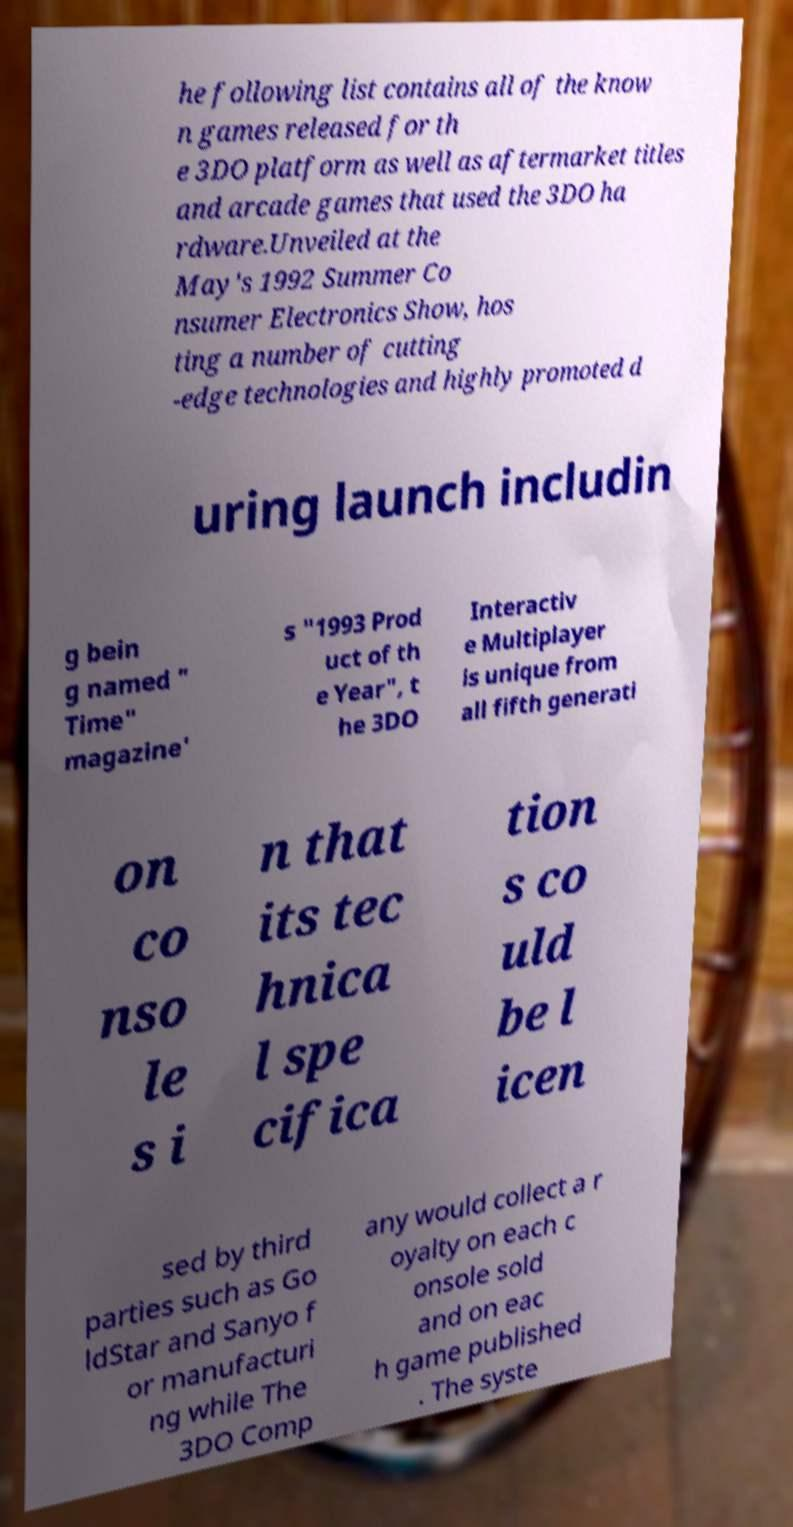Can you read and provide the text displayed in the image?This photo seems to have some interesting text. Can you extract and type it out for me? he following list contains all of the know n games released for th e 3DO platform as well as aftermarket titles and arcade games that used the 3DO ha rdware.Unveiled at the May's 1992 Summer Co nsumer Electronics Show, hos ting a number of cutting -edge technologies and highly promoted d uring launch includin g bein g named " Time" magazine' s "1993 Prod uct of th e Year", t he 3DO Interactiv e Multiplayer is unique from all fifth generati on co nso le s i n that its tec hnica l spe cifica tion s co uld be l icen sed by third parties such as Go ldStar and Sanyo f or manufacturi ng while The 3DO Comp any would collect a r oyalty on each c onsole sold and on eac h game published . The syste 